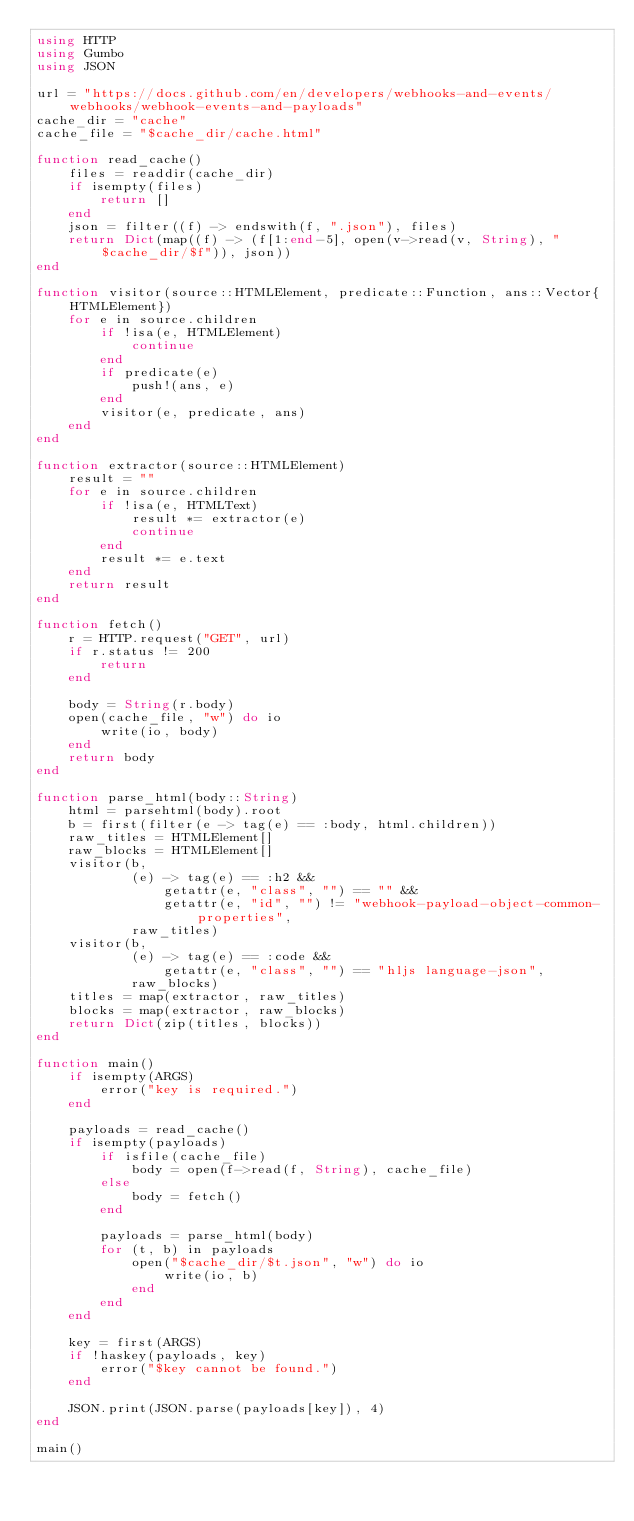Convert code to text. <code><loc_0><loc_0><loc_500><loc_500><_Julia_>using HTTP
using Gumbo
using JSON

url = "https://docs.github.com/en/developers/webhooks-and-events/webhooks/webhook-events-and-payloads"
cache_dir = "cache"
cache_file = "$cache_dir/cache.html"

function read_cache()
    files = readdir(cache_dir)
    if isempty(files)
        return []
    end
    json = filter((f) -> endswith(f, ".json"), files)
    return Dict(map((f) -> (f[1:end-5], open(v->read(v, String), "$cache_dir/$f")), json))
end

function visitor(source::HTMLElement, predicate::Function, ans::Vector{HTMLElement})
    for e in source.children
        if !isa(e, HTMLElement)
            continue
        end
        if predicate(e)
            push!(ans, e)
        end
        visitor(e, predicate, ans)
    end
end

function extractor(source::HTMLElement)
    result = ""
    for e in source.children
        if !isa(e, HTMLText)
            result *= extractor(e)
            continue
        end
        result *= e.text
    end
    return result
end

function fetch()
    r = HTTP.request("GET", url)
    if r.status != 200
        return
    end

    body = String(r.body)
    open(cache_file, "w") do io
        write(io, body)
    end
    return body
end

function parse_html(body::String)
    html = parsehtml(body).root
    b = first(filter(e -> tag(e) == :body, html.children))
    raw_titles = HTMLElement[]
    raw_blocks = HTMLElement[]
    visitor(b,
            (e) -> tag(e) == :h2 &&
                getattr(e, "class", "") == "" &&
                getattr(e, "id", "") != "webhook-payload-object-common-properties",
            raw_titles)
    visitor(b,
            (e) -> tag(e) == :code &&
                getattr(e, "class", "") == "hljs language-json",
            raw_blocks)
    titles = map(extractor, raw_titles)
    blocks = map(extractor, raw_blocks)
    return Dict(zip(titles, blocks))
end

function main()
    if isempty(ARGS)
        error("key is required.")
    end

    payloads = read_cache()
    if isempty(payloads)
        if isfile(cache_file)
            body = open(f->read(f, String), cache_file)
        else
            body = fetch()
        end

        payloads = parse_html(body)
        for (t, b) in payloads
            open("$cache_dir/$t.json", "w") do io
                write(io, b)
            end
        end
    end

    key = first(ARGS)
    if !haskey(payloads, key)
        error("$key cannot be found.")
    end

    JSON.print(JSON.parse(payloads[key]), 4)
end

main()
</code> 